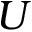Convert formula to latex. <formula><loc_0><loc_0><loc_500><loc_500>U</formula> 